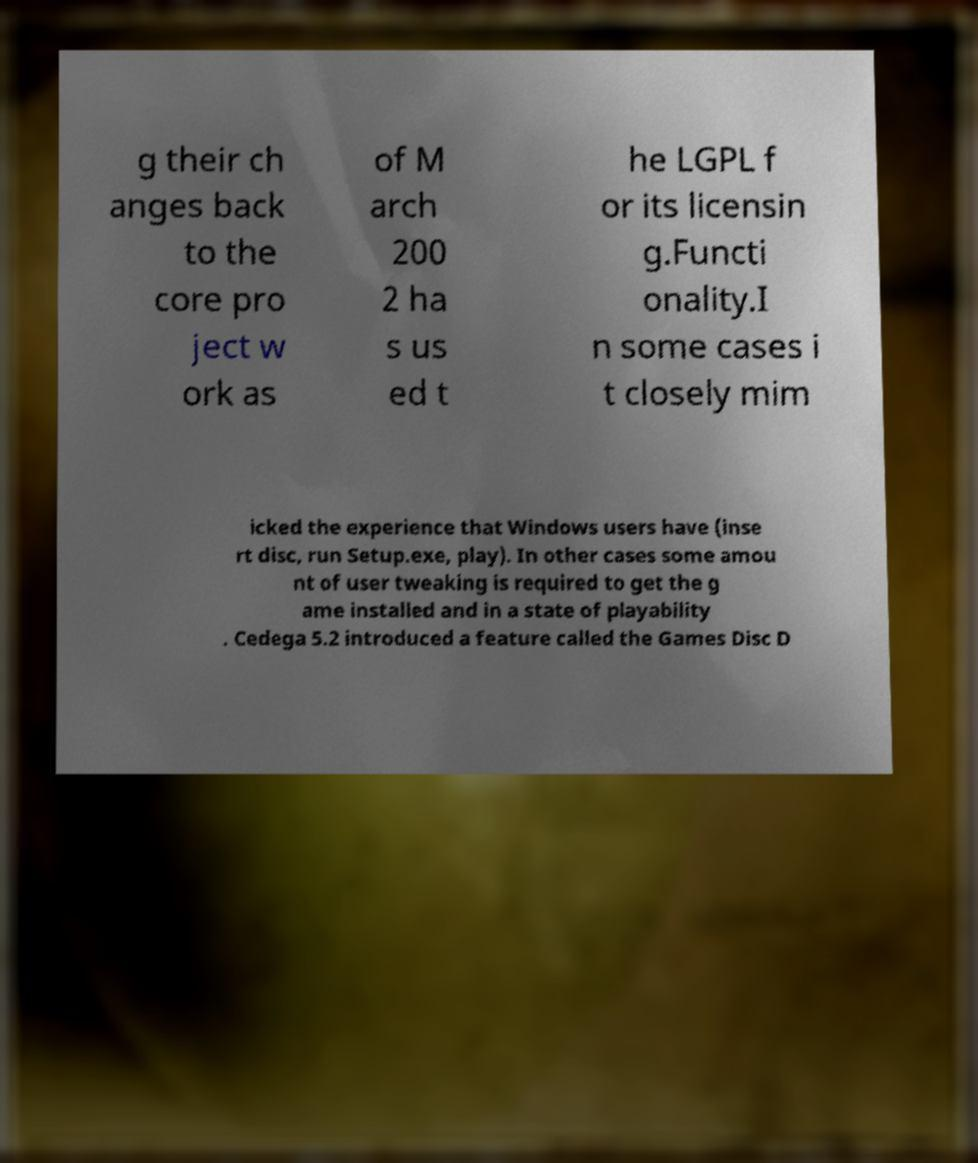Please read and relay the text visible in this image. What does it say? g their ch anges back to the core pro ject w ork as of M arch 200 2 ha s us ed t he LGPL f or its licensin g.Functi onality.I n some cases i t closely mim icked the experience that Windows users have (inse rt disc, run Setup.exe, play). In other cases some amou nt of user tweaking is required to get the g ame installed and in a state of playability . Cedega 5.2 introduced a feature called the Games Disc D 